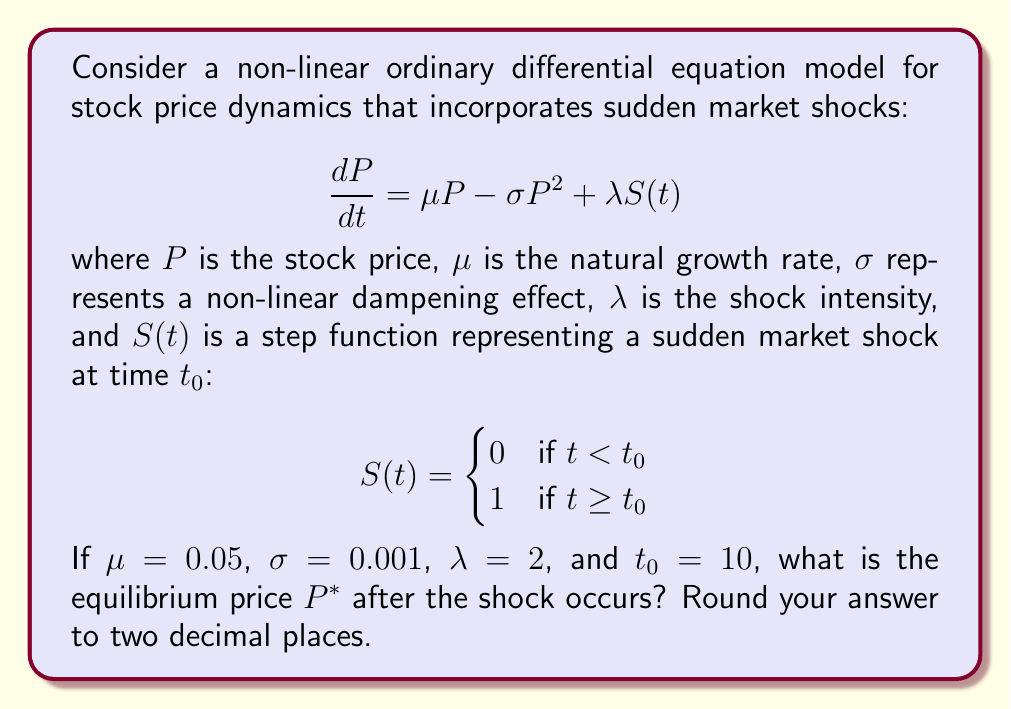Could you help me with this problem? To find the equilibrium price after the shock, we need to solve for $P^*$ when $\frac{dP}{dt} = 0$ and $t \geq t_0$. 

1) Set the differential equation to zero:
   $$0 = \mu P^* - \sigma (P^*)^2 + \lambda S(t)$$

2) Since $t \geq t_0$, $S(t) = 1$:
   $$0 = \mu P^* - \sigma (P^*)^2 + \lambda$$

3) Substitute the given values:
   $$0 = 0.05P^* - 0.001(P^*)^2 + 2$$

4) Rearrange to standard quadratic form:
   $$0.001(P^*)^2 - 0.05P^* - 2 = 0$$

5) Use the quadratic formula $x = \frac{-b \pm \sqrt{b^2 - 4ac}}{2a}$:

   $$P^* = \frac{0.05 \pm \sqrt{0.05^2 - 4(0.001)(-2)}}{2(0.001)}$$

6) Simplify:
   $$P^* = \frac{0.05 \pm \sqrt{0.0025 + 0.008}}{0.002}$$
   $$P^* = \frac{0.05 \pm \sqrt{0.0105}}{0.002}$$
   $$P^* = \frac{0.05 \pm 0.1025}{0.002}$$

7) This gives us two solutions:
   $$P^* = \frac{0.05 + 0.1025}{0.002} = 76.25$$
   $$P^* = \frac{0.05 - 0.1025}{0.002} = -26.25$$

8) Since stock prices cannot be negative, we discard the negative solution.

Therefore, the equilibrium price after the shock is approximately 76.25.
Answer: $76.25 